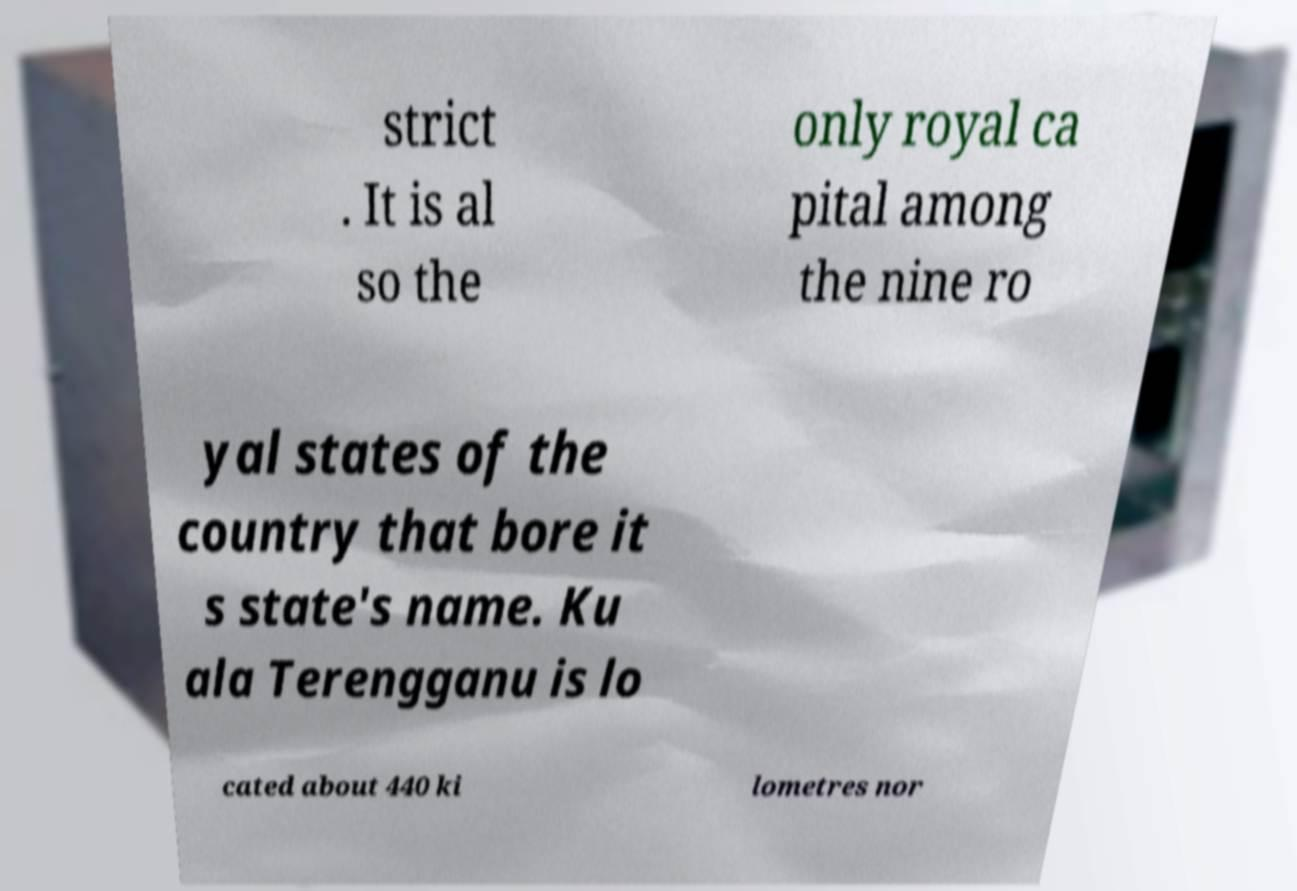Please identify and transcribe the text found in this image. strict . It is al so the only royal ca pital among the nine ro yal states of the country that bore it s state's name. Ku ala Terengganu is lo cated about 440 ki lometres nor 